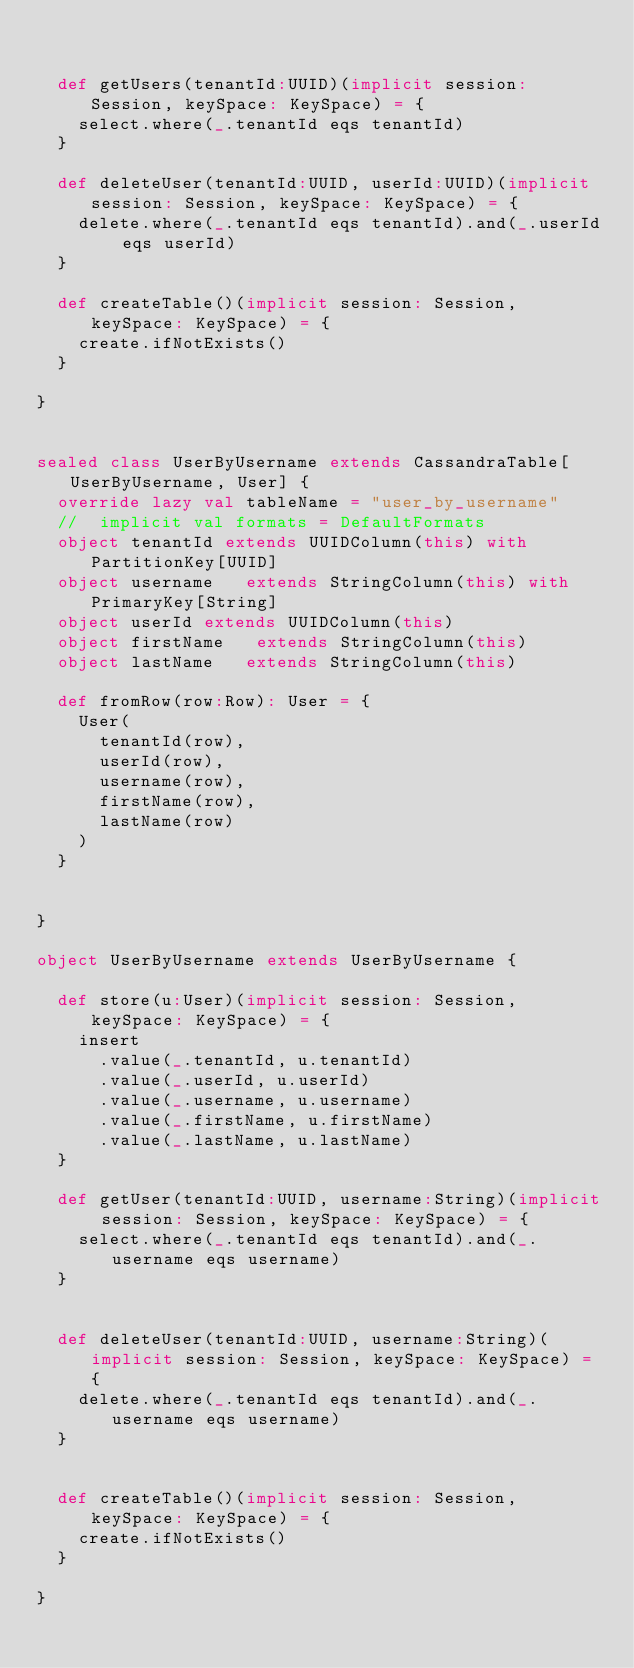Convert code to text. <code><loc_0><loc_0><loc_500><loc_500><_Scala_>
  
  def getUsers(tenantId:UUID)(implicit session: Session, keySpace: KeySpace) = {
    select.where(_.tenantId eqs tenantId)
  }
  
  def deleteUser(tenantId:UUID, userId:UUID)(implicit session: Session, keySpace: KeySpace) = {
    delete.where(_.tenantId eqs tenantId).and(_.userId eqs userId)
  }
  
  def createTable()(implicit session: Session, keySpace: KeySpace) = {
    create.ifNotExists()
  }

}


sealed class UserByUsername extends CassandraTable[UserByUsername, User] {
  override lazy val tableName = "user_by_username"
  //  implicit val formats = DefaultFormats
  object tenantId extends UUIDColumn(this) with PartitionKey[UUID]
  object username   extends StringColumn(this) with PrimaryKey[String]
  object userId extends UUIDColumn(this)
  object firstName   extends StringColumn(this)
  object lastName   extends StringColumn(this)

  def fromRow(row:Row): User = {
    User(
      tenantId(row),
      userId(row),
      username(row),
      firstName(row),
      lastName(row)
    )
  }


}

object UserByUsername extends UserByUsername {
  
  def store(u:User)(implicit session: Session, keySpace: KeySpace) = {
    insert
      .value(_.tenantId, u.tenantId)
      .value(_.userId, u.userId)
      .value(_.username, u.username)
      .value(_.firstName, u.firstName)
      .value(_.lastName, u.lastName)
  }
  
  def getUser(tenantId:UUID, username:String)(implicit session: Session, keySpace: KeySpace) = {
    select.where(_.tenantId eqs tenantId).and(_.username eqs username)
  }

  
  def deleteUser(tenantId:UUID, username:String)(implicit session: Session, keySpace: KeySpace) = {
    delete.where(_.tenantId eqs tenantId).and(_.username eqs username)
  }
      
    
  def createTable()(implicit session: Session, keySpace: KeySpace) = {
    create.ifNotExists()
  }
    
}

</code> 